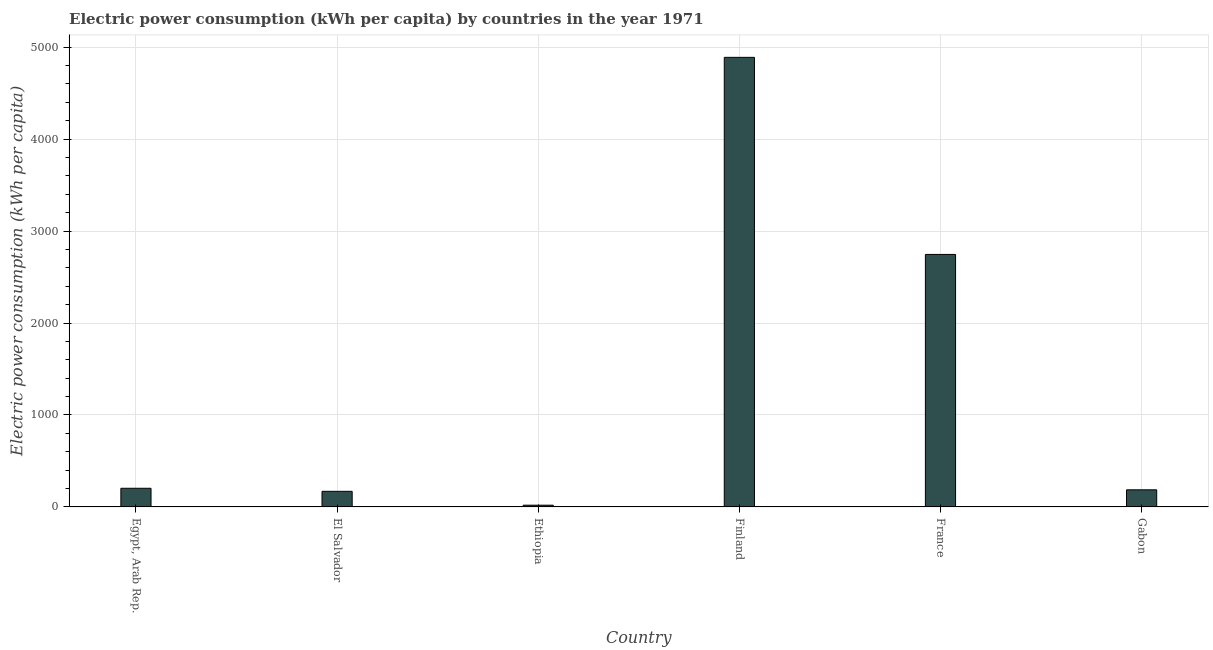Does the graph contain grids?
Provide a short and direct response. Yes. What is the title of the graph?
Offer a very short reply. Electric power consumption (kWh per capita) by countries in the year 1971. What is the label or title of the Y-axis?
Keep it short and to the point. Electric power consumption (kWh per capita). What is the electric power consumption in Ethiopia?
Give a very brief answer. 18.87. Across all countries, what is the maximum electric power consumption?
Provide a short and direct response. 4889.5. Across all countries, what is the minimum electric power consumption?
Give a very brief answer. 18.87. In which country was the electric power consumption maximum?
Your response must be concise. Finland. In which country was the electric power consumption minimum?
Offer a terse response. Ethiopia. What is the sum of the electric power consumption?
Your answer should be compact. 8213.3. What is the difference between the electric power consumption in El Salvador and Gabon?
Your answer should be very brief. -16.42. What is the average electric power consumption per country?
Offer a terse response. 1368.88. What is the median electric power consumption?
Give a very brief answer. 194.52. What is the ratio of the electric power consumption in El Salvador to that in Ethiopia?
Keep it short and to the point. 8.99. Is the electric power consumption in El Salvador less than that in France?
Provide a succinct answer. Yes. Is the difference between the electric power consumption in Egypt, Arab Rep. and Finland greater than the difference between any two countries?
Give a very brief answer. No. What is the difference between the highest and the second highest electric power consumption?
Your response must be concise. 2143.34. Is the sum of the electric power consumption in Ethiopia and Finland greater than the maximum electric power consumption across all countries?
Provide a succinct answer. Yes. What is the difference between the highest and the lowest electric power consumption?
Offer a terse response. 4870.63. Are all the bars in the graph horizontal?
Provide a short and direct response. No. What is the difference between two consecutive major ticks on the Y-axis?
Your answer should be very brief. 1000. What is the Electric power consumption (kWh per capita) in Egypt, Arab Rep.?
Offer a terse response. 202.92. What is the Electric power consumption (kWh per capita) in El Salvador?
Provide a short and direct response. 169.71. What is the Electric power consumption (kWh per capita) in Ethiopia?
Offer a very short reply. 18.87. What is the Electric power consumption (kWh per capita) in Finland?
Offer a very short reply. 4889.5. What is the Electric power consumption (kWh per capita) in France?
Offer a very short reply. 2746.17. What is the Electric power consumption (kWh per capita) in Gabon?
Your answer should be compact. 186.13. What is the difference between the Electric power consumption (kWh per capita) in Egypt, Arab Rep. and El Salvador?
Your answer should be very brief. 33.21. What is the difference between the Electric power consumption (kWh per capita) in Egypt, Arab Rep. and Ethiopia?
Ensure brevity in your answer.  184.04. What is the difference between the Electric power consumption (kWh per capita) in Egypt, Arab Rep. and Finland?
Offer a very short reply. -4686.59. What is the difference between the Electric power consumption (kWh per capita) in Egypt, Arab Rep. and France?
Give a very brief answer. -2543.25. What is the difference between the Electric power consumption (kWh per capita) in Egypt, Arab Rep. and Gabon?
Give a very brief answer. 16.79. What is the difference between the Electric power consumption (kWh per capita) in El Salvador and Ethiopia?
Give a very brief answer. 150.84. What is the difference between the Electric power consumption (kWh per capita) in El Salvador and Finland?
Give a very brief answer. -4719.79. What is the difference between the Electric power consumption (kWh per capita) in El Salvador and France?
Provide a succinct answer. -2576.46. What is the difference between the Electric power consumption (kWh per capita) in El Salvador and Gabon?
Ensure brevity in your answer.  -16.42. What is the difference between the Electric power consumption (kWh per capita) in Ethiopia and Finland?
Provide a short and direct response. -4870.63. What is the difference between the Electric power consumption (kWh per capita) in Ethiopia and France?
Offer a terse response. -2727.29. What is the difference between the Electric power consumption (kWh per capita) in Ethiopia and Gabon?
Keep it short and to the point. -167.25. What is the difference between the Electric power consumption (kWh per capita) in Finland and France?
Your answer should be very brief. 2143.34. What is the difference between the Electric power consumption (kWh per capita) in Finland and Gabon?
Provide a succinct answer. 4703.38. What is the difference between the Electric power consumption (kWh per capita) in France and Gabon?
Offer a very short reply. 2560.04. What is the ratio of the Electric power consumption (kWh per capita) in Egypt, Arab Rep. to that in El Salvador?
Make the answer very short. 1.2. What is the ratio of the Electric power consumption (kWh per capita) in Egypt, Arab Rep. to that in Ethiopia?
Offer a terse response. 10.75. What is the ratio of the Electric power consumption (kWh per capita) in Egypt, Arab Rep. to that in Finland?
Ensure brevity in your answer.  0.04. What is the ratio of the Electric power consumption (kWh per capita) in Egypt, Arab Rep. to that in France?
Offer a terse response. 0.07. What is the ratio of the Electric power consumption (kWh per capita) in Egypt, Arab Rep. to that in Gabon?
Provide a succinct answer. 1.09. What is the ratio of the Electric power consumption (kWh per capita) in El Salvador to that in Ethiopia?
Keep it short and to the point. 8.99. What is the ratio of the Electric power consumption (kWh per capita) in El Salvador to that in Finland?
Your answer should be compact. 0.04. What is the ratio of the Electric power consumption (kWh per capita) in El Salvador to that in France?
Give a very brief answer. 0.06. What is the ratio of the Electric power consumption (kWh per capita) in El Salvador to that in Gabon?
Keep it short and to the point. 0.91. What is the ratio of the Electric power consumption (kWh per capita) in Ethiopia to that in Finland?
Your answer should be compact. 0. What is the ratio of the Electric power consumption (kWh per capita) in Ethiopia to that in France?
Your answer should be compact. 0.01. What is the ratio of the Electric power consumption (kWh per capita) in Ethiopia to that in Gabon?
Your answer should be very brief. 0.1. What is the ratio of the Electric power consumption (kWh per capita) in Finland to that in France?
Your answer should be compact. 1.78. What is the ratio of the Electric power consumption (kWh per capita) in Finland to that in Gabon?
Keep it short and to the point. 26.27. What is the ratio of the Electric power consumption (kWh per capita) in France to that in Gabon?
Keep it short and to the point. 14.75. 